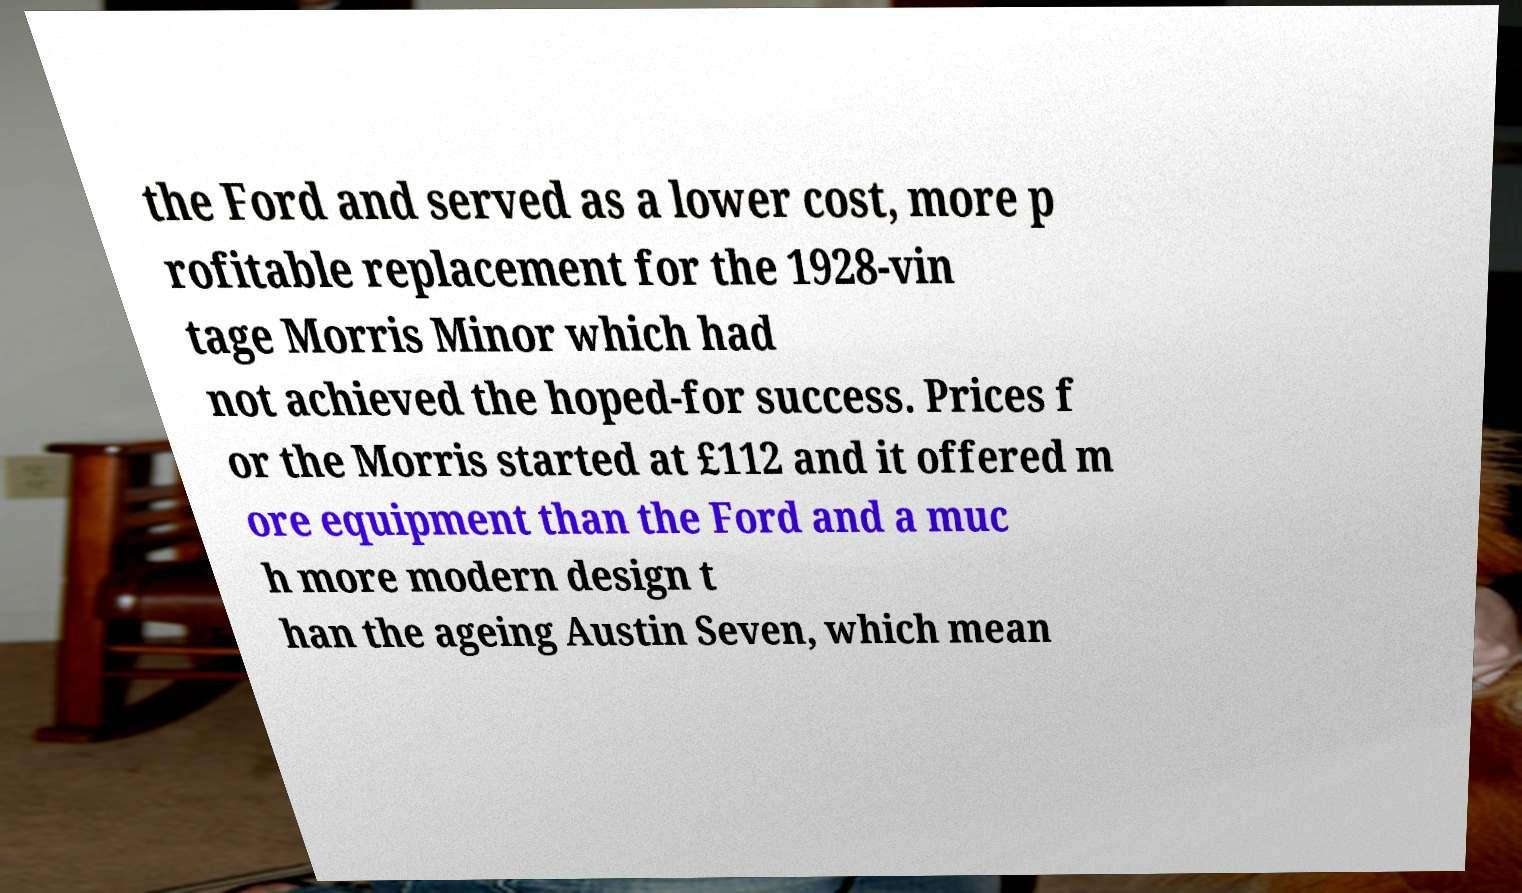For documentation purposes, I need the text within this image transcribed. Could you provide that? the Ford and served as a lower cost, more p rofitable replacement for the 1928-vin tage Morris Minor which had not achieved the hoped-for success. Prices f or the Morris started at £112 and it offered m ore equipment than the Ford and a muc h more modern design t han the ageing Austin Seven, which mean 